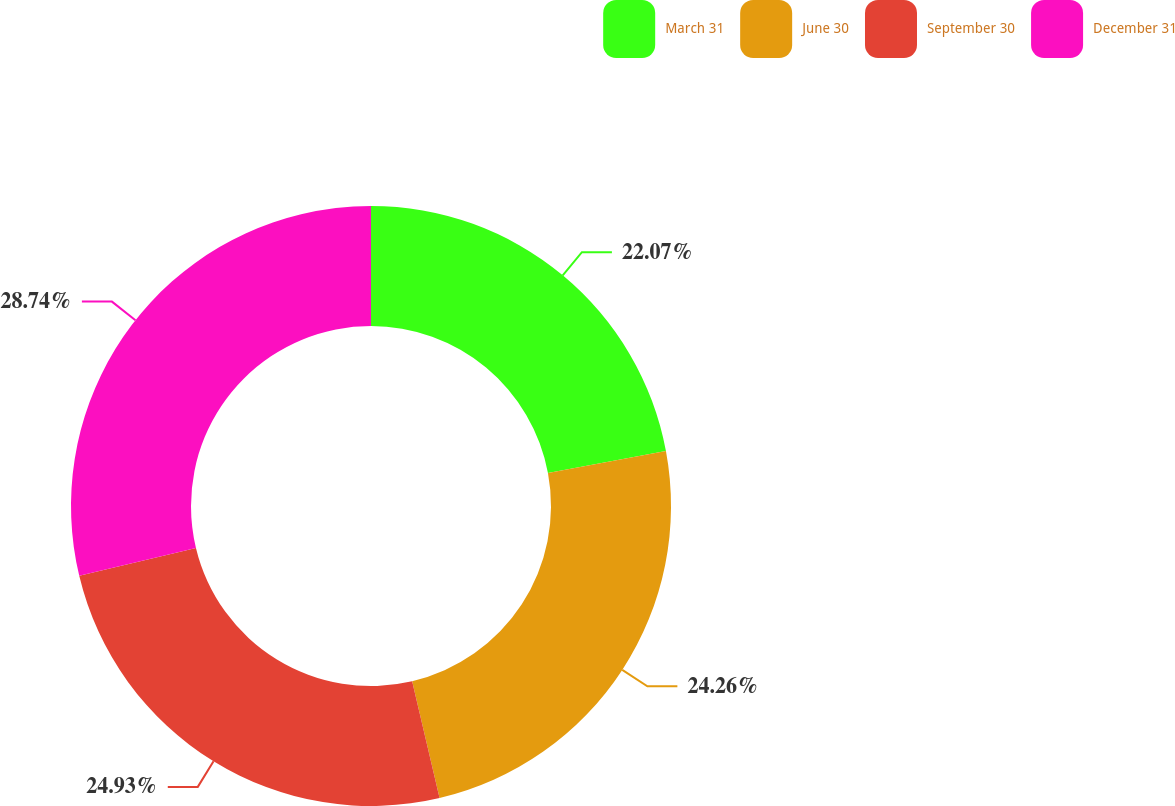Convert chart to OTSL. <chart><loc_0><loc_0><loc_500><loc_500><pie_chart><fcel>March 31<fcel>June 30<fcel>September 30<fcel>December 31<nl><fcel>22.07%<fcel>24.26%<fcel>24.93%<fcel>28.74%<nl></chart> 